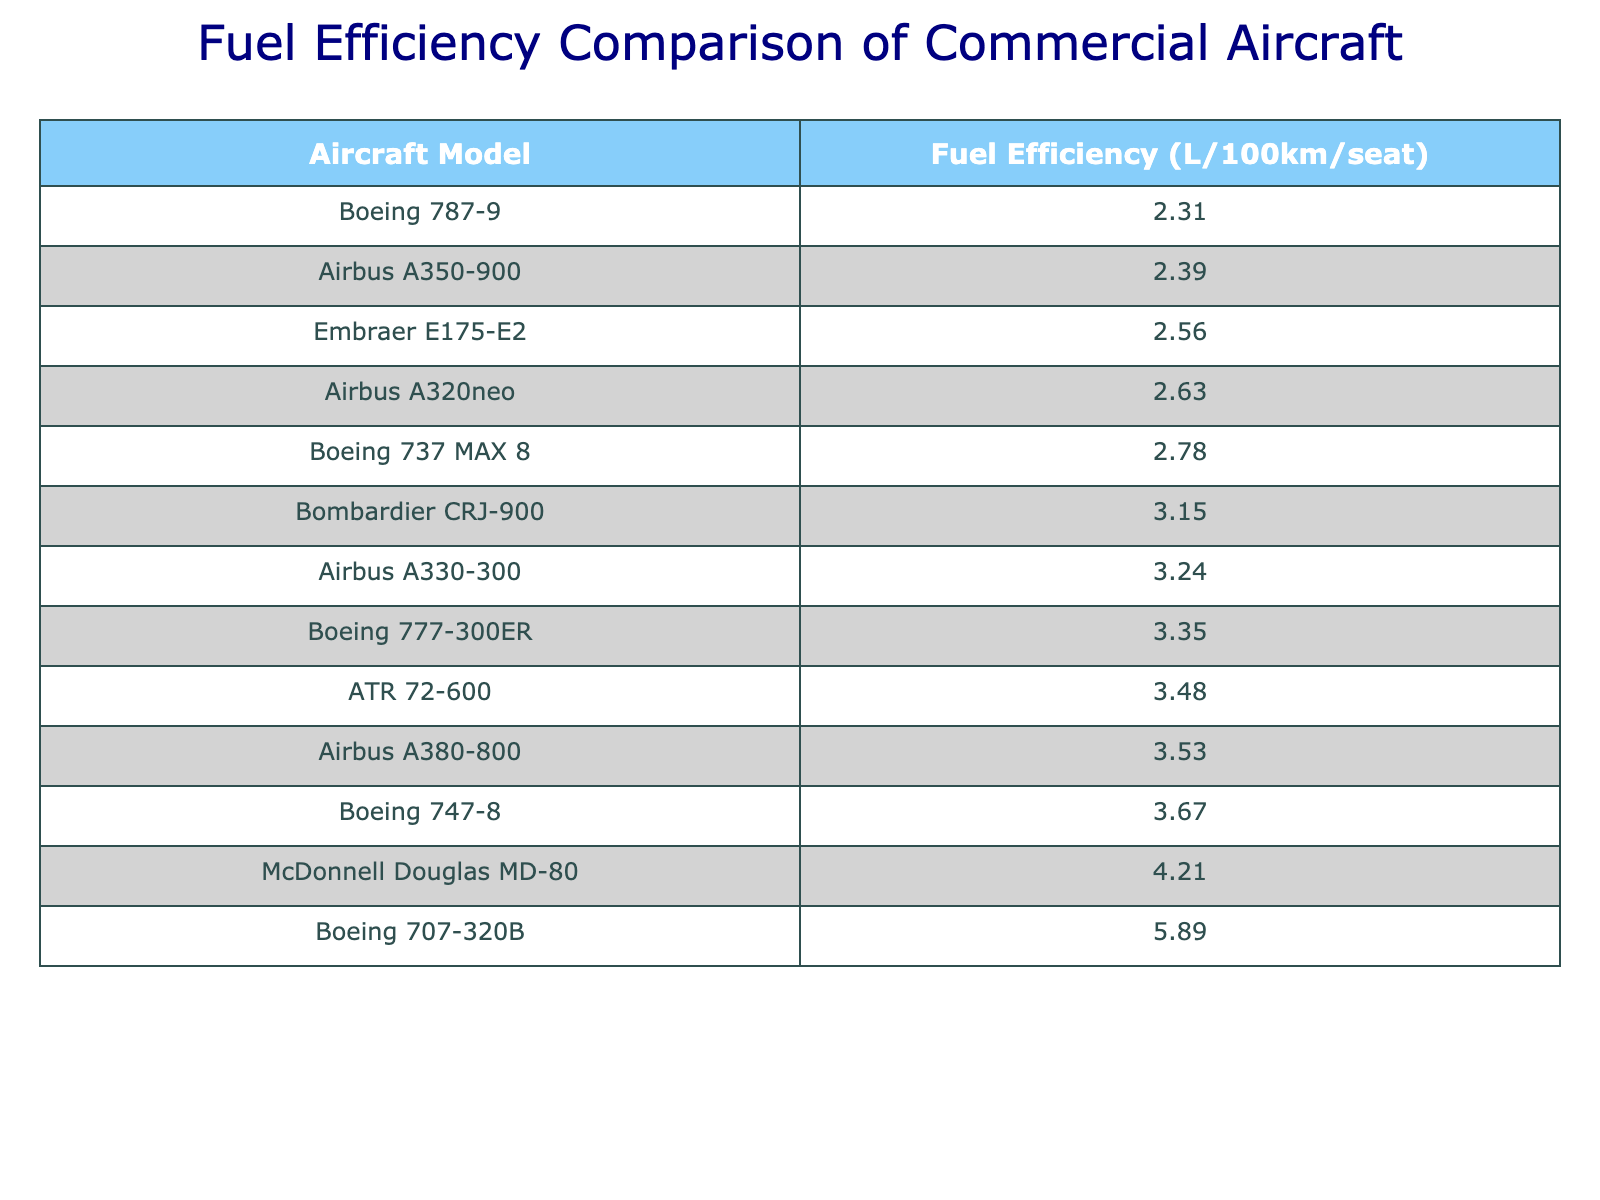What is the fuel efficiency of the Boeing 787-9? The table shows the specific fuel efficiency value for the Boeing 787-9 listed as 2.31 L/100km/seat.
Answer: 2.31 L/100km/seat Which aircraft has the lowest fuel efficiency? By examining the table, the aircraft with the lowest fuel efficiency value is the Boeing 707-320B at 5.89 L/100km/seat.
Answer: Boeing 707-320B What is the difference in fuel efficiency between the Airbus A380-800 and the Boeing 737 MAX 8? The Airbus A380-800 has a fuel efficiency of 3.53 L/100km/seat and the Boeing 737 MAX 8 has 2.78 L/100km/seat. Calculating the difference: 3.53 - 2.78 = 0.75 L/100km/seat.
Answer: 0.75 L/100km/seat What is the average fuel efficiency of the aircraft listed in the table? To find the average, add all the fuel efficiency values: 2.31 + 2.39 + 2.56 + 2.63 + 2.78 + 3.15 + 3.24 + 3.35 + 3.48 + 3.53 + 3.67 + 4.21 + 5.89 = 43.20. There are 13 aircraft, so the average is 43.20 / 13 ≈ 3.33 L/100km/seat.
Answer: 3.33 L/100km/seat Is the fuel efficiency of the Airbus A350-900 better than that of the Boeing 747-8? The fuel efficiency of the Airbus A350-900 is 2.39 L/100km/seat, while the Boeing 747-8 has 3.67 L/100km/seat. Since 2.39 is less than 3.67, the fuel efficiency of the A350-900 is indeed better.
Answer: Yes How many aircraft have a fuel efficiency greater than 3.00 L/100km/seat? By checking the table, the following aircraft have a fuel efficiency greater than 3.00 L/100km/seat: Bombardier CRJ-900, Airbus A330-300, Boeing 777-300ER, ATR 72-600, Airbus A380-800, Boeing 747-8, McDonnell Douglas MD-80, Boeing 707-320B. This totals to 8 aircraft.
Answer: 8 What is the sum of fuel efficiency values for the top three most efficient aircraft? The top three most efficient aircraft are Boeing 787-9 (2.31), Airbus A350-900 (2.39), and Embraer E175-E2 (2.56). Adding these gives: 2.31 + 2.39 + 2.56 = 7.26 L/100km/seat.
Answer: 7.26 L/100km/seat Which aircraft models have fuel efficiency values between 2.50 and 3.00 L/100km/seat? The table shows that the following aircraft have fuel efficiency values falling between 2.50 and 3.00 L/100km/seat: Embraer E175-E2 (2.56), Airbus A320neo (2.63), and Boeing 737 MAX 8 (2.78).
Answer: Embraer E175-E2, Airbus A320neo, Boeing 737 MAX 8 What is the ranking of the Boeing 777-300ER in terms of fuel efficiency among the listed aircraft? The Boeing 777-300ER has a fuel efficiency of 3.35 L/100km/seat. By ranking the values from lowest to highest, it holds the 8th position in the list.
Answer: 8th place Are there any aircraft with a fuel efficiency of 3.00 L/100km/seat or less? Yes, examining the table reveals that the following aircraft have a fuel efficiency of 3.00 L/100km/seat or less: Boeing 787-9, Airbus A350-900, Embraer E175-E2, Airbus A320neo, Boeing 737 MAX 8, and Bombardier CRJ-900.
Answer: Yes 